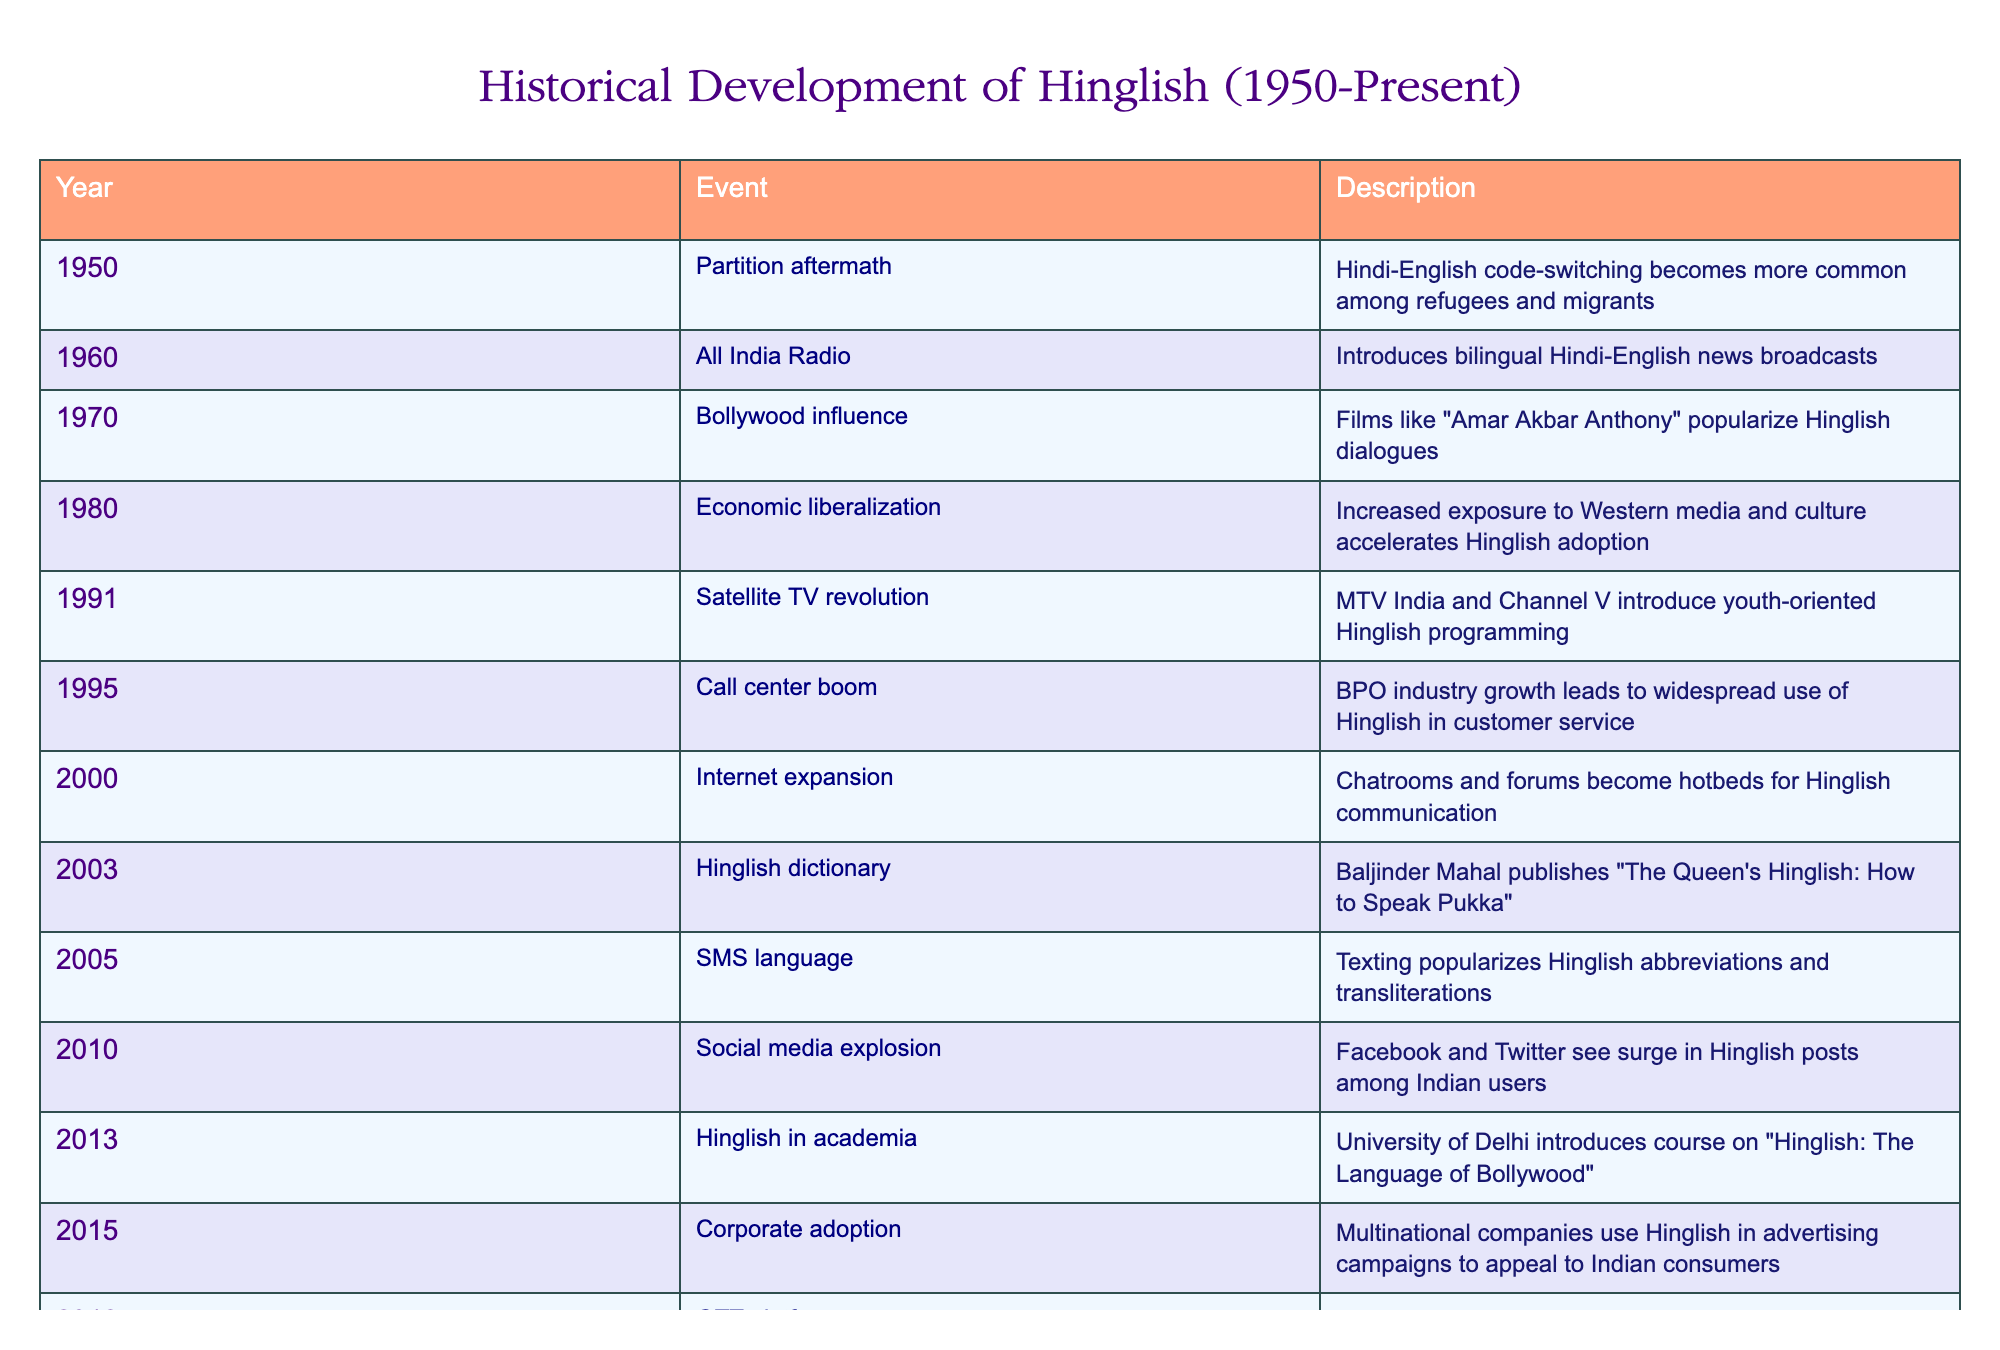What year did the OTT platforms start producing Hinglish content? From the table, the event related to OTT platforms is in the year 2018, where Netflix and Amazon Prime began producing Hinglish content for Indian audiences.
Answer: 2018 What impact did the call center boom have on Hinglish? The call center boom in 1995 led to the widespread use of Hinglish in customer service, as it became common for BPO industries to interact with clients using a blend of Hindi and English.
Answer: Widespread use in customer service In which year did the Hinglish dictionary get published? The Hinglish dictionary was published in the year 2003 by Baljinder Mahal, as indicated in the table.
Answer: 2003 Was there a significant event in 1980 that influenced Hinglish? Yes, the economic liberalization in 1980 increased exposure to Western media and culture, which accelerated the adoption of Hinglish.
Answer: Yes How many events mentioned in the table occurred after the year 2010? By reviewing the table, the events listed after 2010 are: the social media explosion in 2010, Hinglish in academia in 2013, corporate adoption in 2015, OTT platforms in 2018, COVID-19 pandemic in 2020, and global recognition in 2022. This gives us a total of 6 events.
Answer: 6 events What is the relationship between Bollywood and Hinglish in the 1970s? In the 1970s, the influence of Bollywood increased with films like "Amar Akbar Anthony," which popularized Hinglish dialogues, blending Hindi and English in mainstream cinema.
Answer: Films popularized Hinglish dialogues What percentage of the events in the timeline are associated with media influence? Looking at the table, the events linked to media influence are: All India Radio in 1960, Bollywood influence in 1970, the satellite TV revolution in 1991, Internet expansion in 2000, social media explosion in 2010, OTT platforms in 2018, making a total of 6 events out of 14. To get the percentage, (6/14) * 100 = approximately 42.86%.
Answer: Approximately 42.86% Did the Oxford English Dictionary add Hinglish words in 2022? Yes, the table states that in 2022, the Oxford English Dictionary added several Hinglish words in its latest edition, indicating a recognition of the language's growth.
Answer: Yes How many years are there between the event of economic liberalization and the publication of the Hinglish dictionary? The economic liberalization occurred in 1980, and the Hinglish dictionary was published in 2003. The difference between these years is 2003 - 1980 = 23 years.
Answer: 23 years 